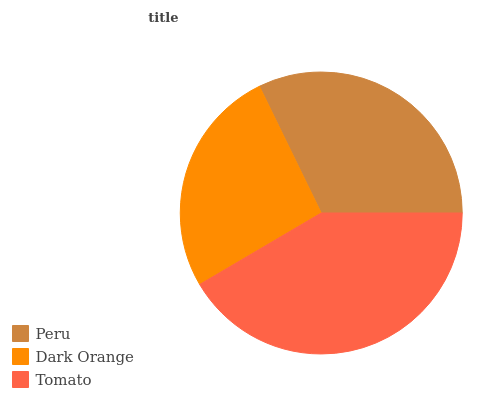Is Dark Orange the minimum?
Answer yes or no. Yes. Is Tomato the maximum?
Answer yes or no. Yes. Is Tomato the minimum?
Answer yes or no. No. Is Dark Orange the maximum?
Answer yes or no. No. Is Tomato greater than Dark Orange?
Answer yes or no. Yes. Is Dark Orange less than Tomato?
Answer yes or no. Yes. Is Dark Orange greater than Tomato?
Answer yes or no. No. Is Tomato less than Dark Orange?
Answer yes or no. No. Is Peru the high median?
Answer yes or no. Yes. Is Peru the low median?
Answer yes or no. Yes. Is Dark Orange the high median?
Answer yes or no. No. Is Dark Orange the low median?
Answer yes or no. No. 